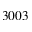<formula> <loc_0><loc_0><loc_500><loc_500>3 0 0 3</formula> 